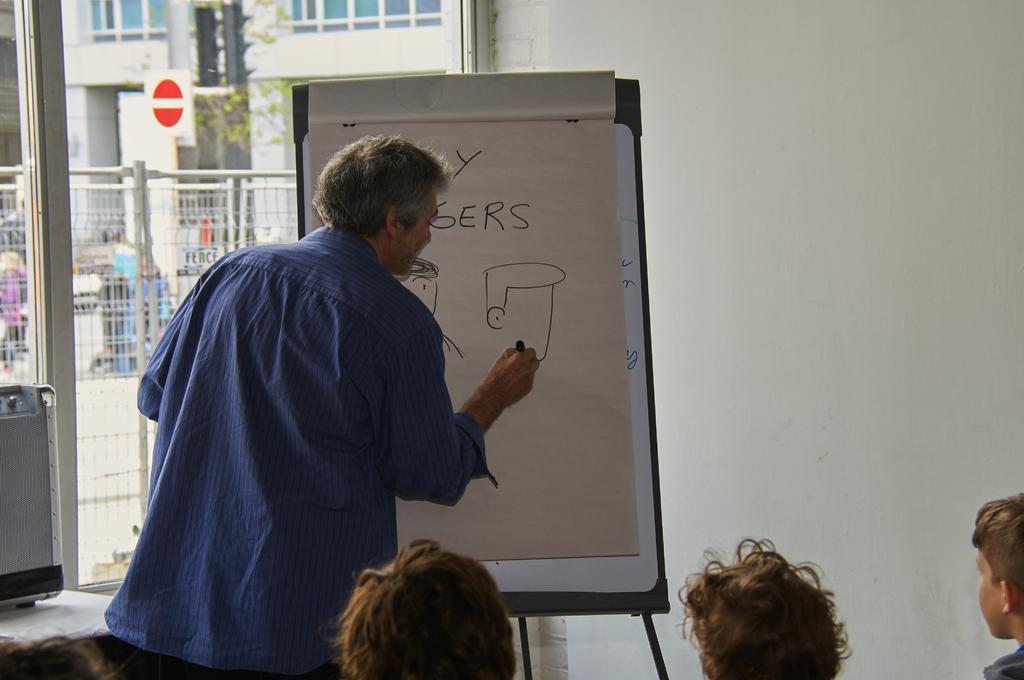What is the man in the image doing? The man is standing in the image and writing on a board. What is the man wearing in the image? The man is wearing a blue shirt in the image. What can be seen on the left side of the image? There is a glass wall on the left side of the image. What is located outside the glass wall? Outside the glass wall, there is an iron gate. What type of health advice is the man giving to the farmer in the image? There is no farmer present in the image, and the man is not giving any health advice; he is writing on a board. What is the man using to secure the chain to the iron gate in the image? There is no chain present in the image, and the man is not securing anything to the iron gate; he is writing on a board. 